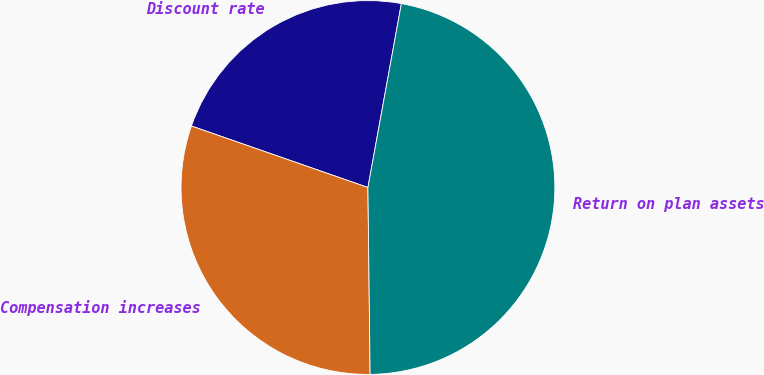Convert chart. <chart><loc_0><loc_0><loc_500><loc_500><pie_chart><fcel>Discount rate<fcel>Compensation increases<fcel>Return on plan assets<nl><fcel>22.53%<fcel>30.52%<fcel>46.95%<nl></chart> 